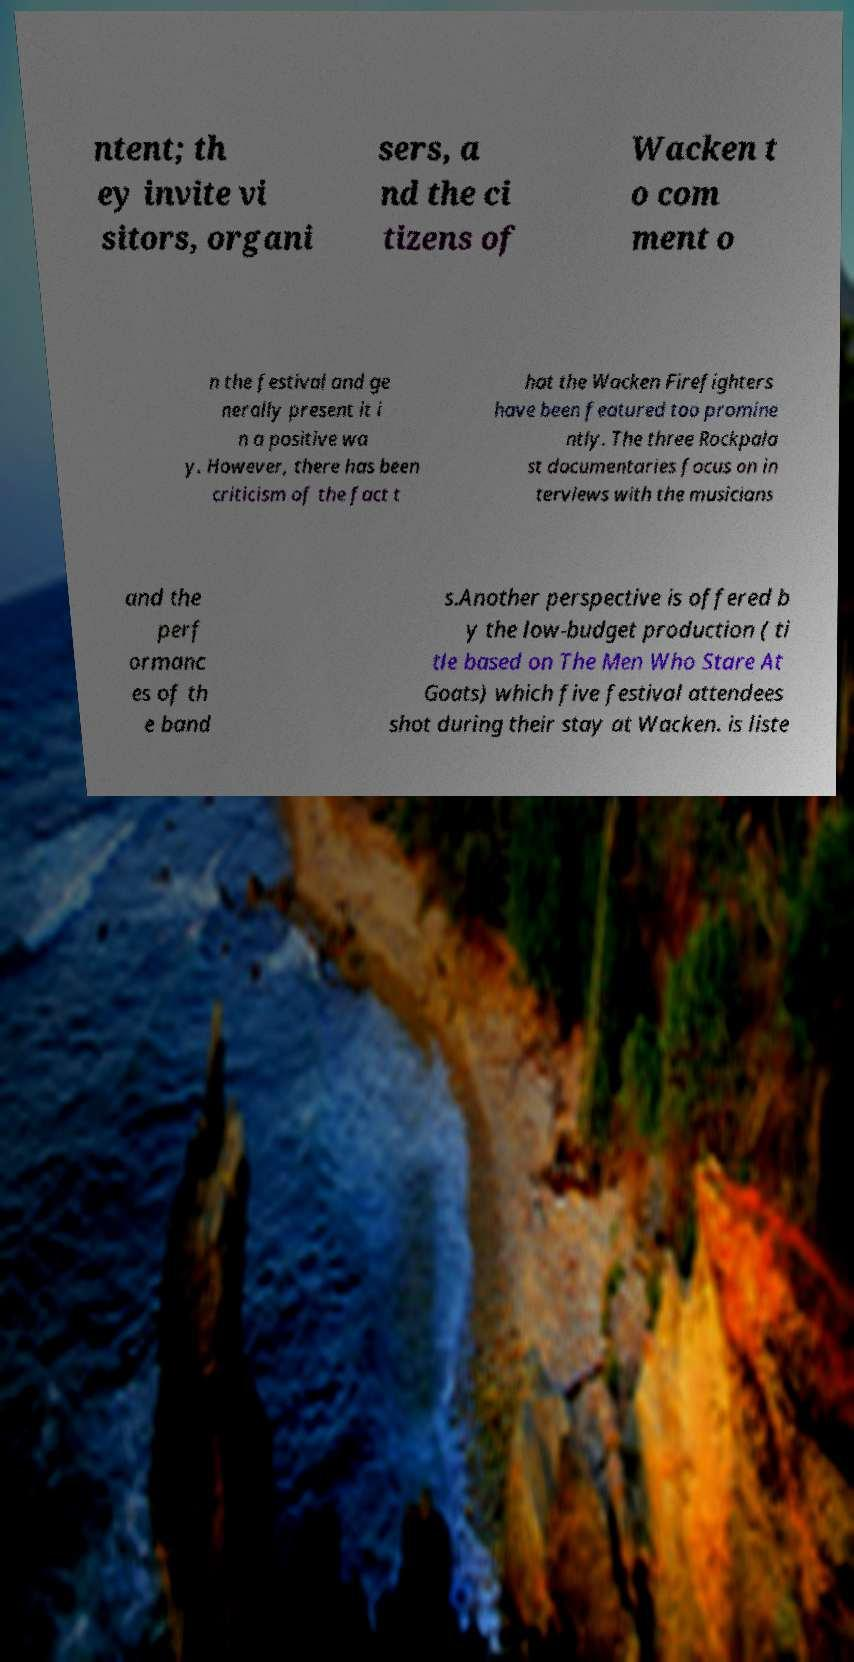Can you accurately transcribe the text from the provided image for me? ntent; th ey invite vi sitors, organi sers, a nd the ci tizens of Wacken t o com ment o n the festival and ge nerally present it i n a positive wa y. However, there has been criticism of the fact t hat the Wacken Firefighters have been featured too promine ntly. The three Rockpala st documentaries focus on in terviews with the musicians and the perf ormanc es of th e band s.Another perspective is offered b y the low-budget production ( ti tle based on The Men Who Stare At Goats) which five festival attendees shot during their stay at Wacken. is liste 